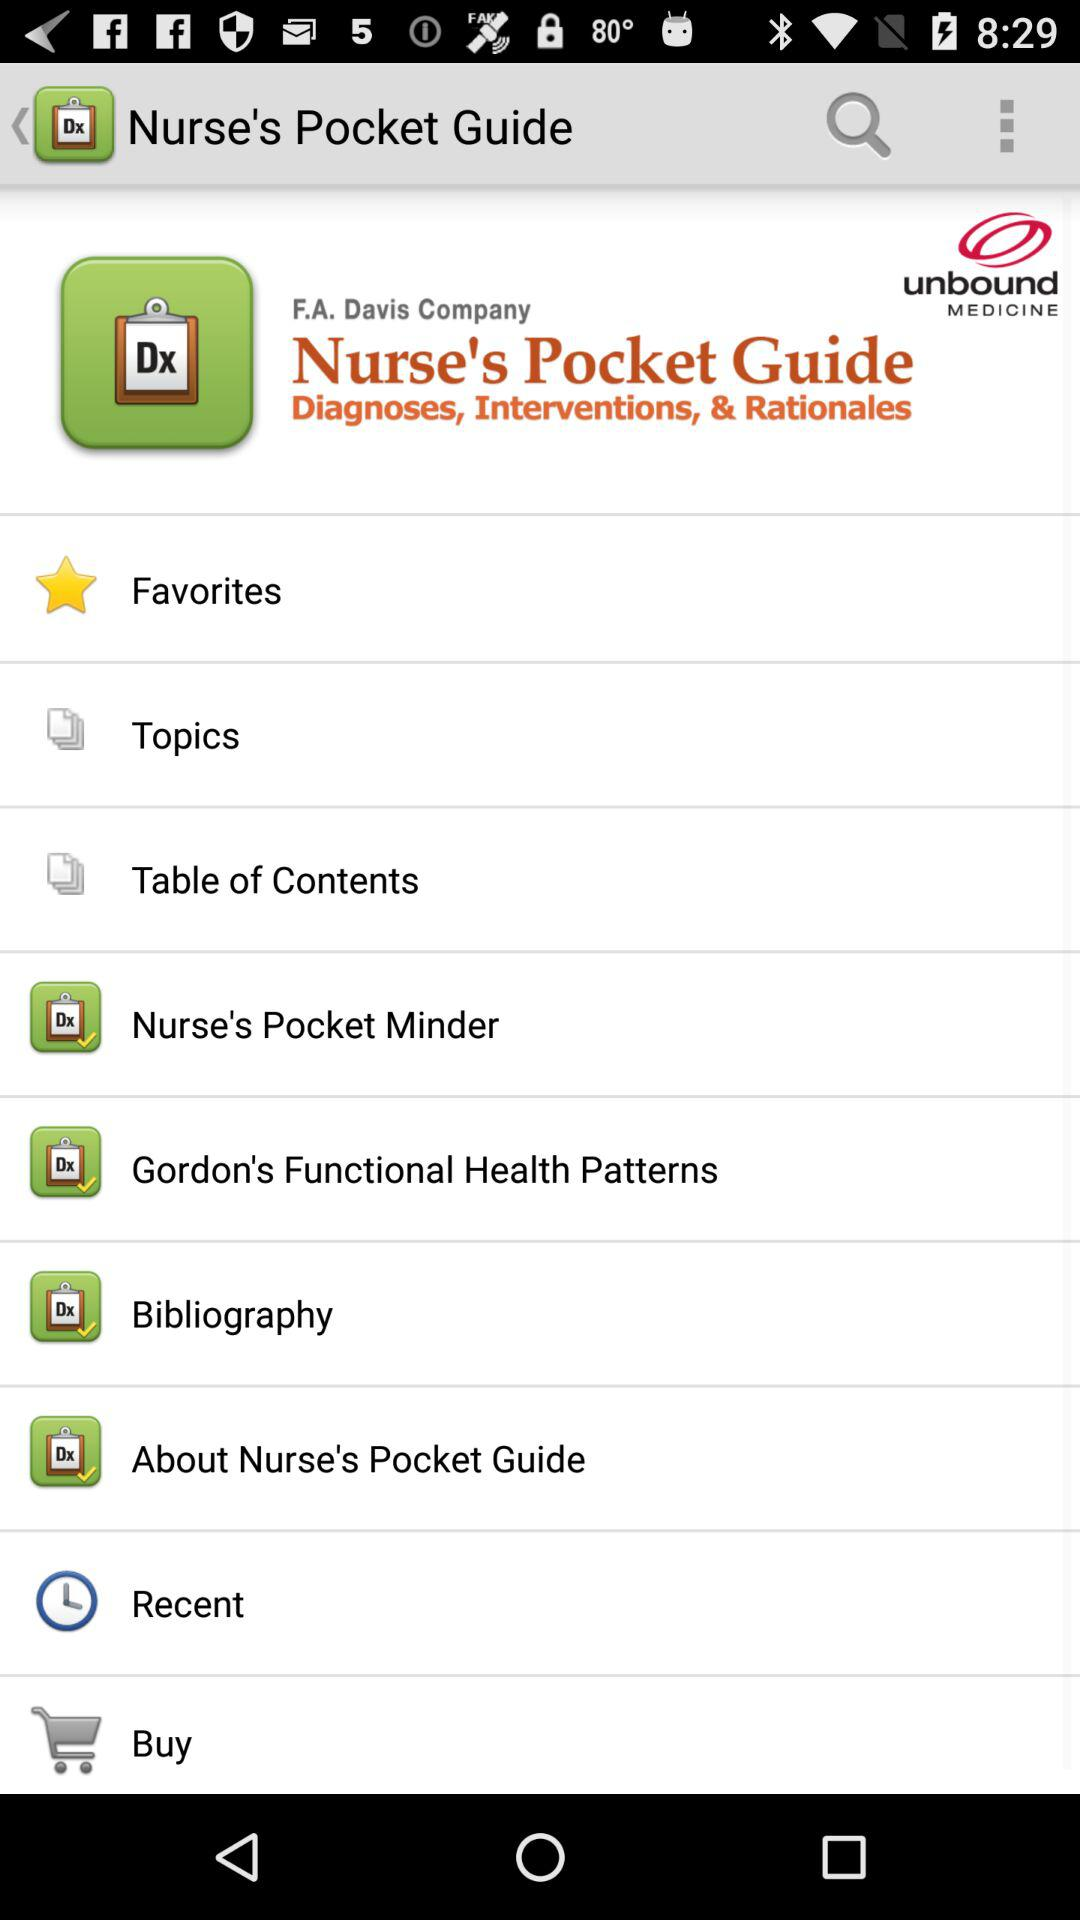What is the app name? The app name is "Nurse's Pocket Guide". 